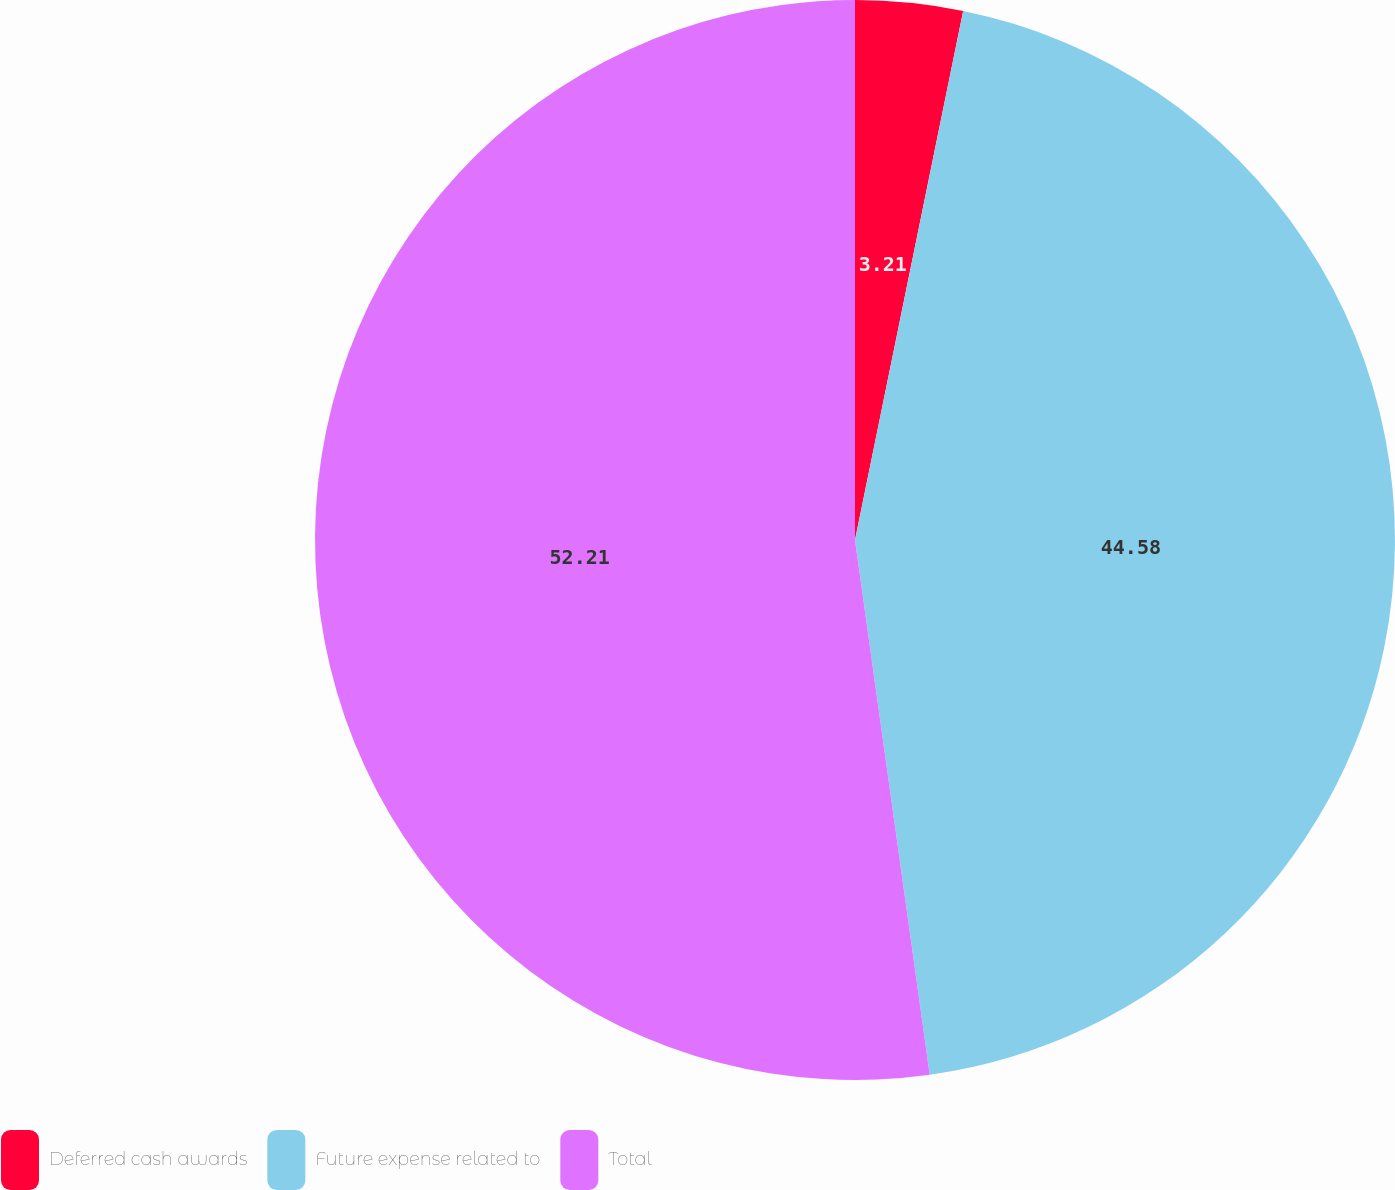Convert chart. <chart><loc_0><loc_0><loc_500><loc_500><pie_chart><fcel>Deferred cash awards<fcel>Future expense related to<fcel>Total<nl><fcel>3.21%<fcel>44.58%<fcel>52.21%<nl></chart> 